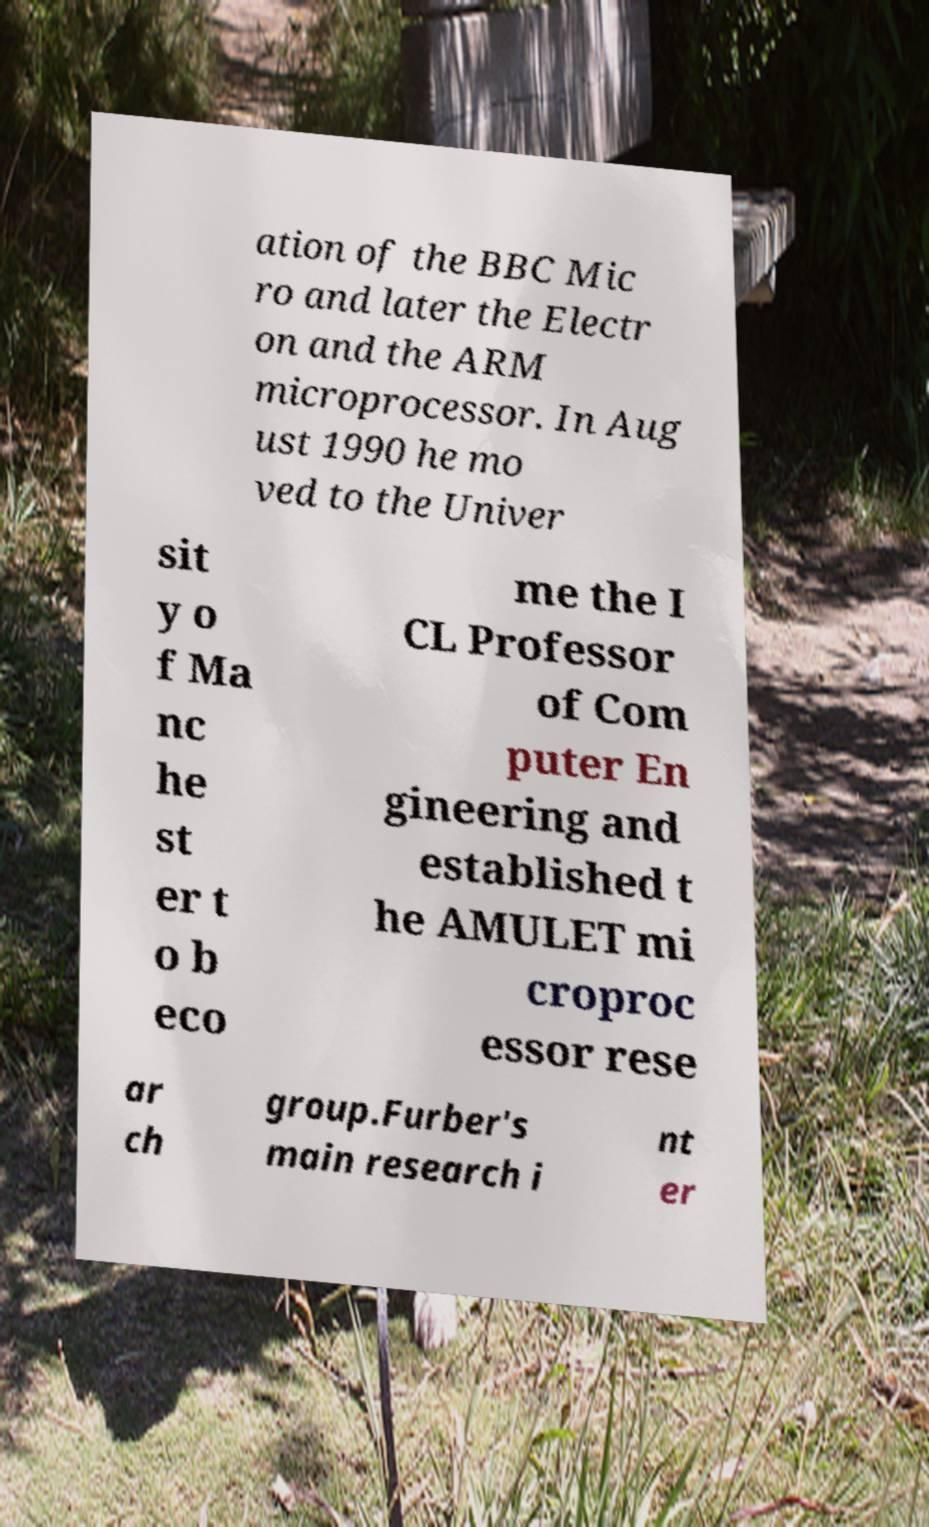Please identify and transcribe the text found in this image. ation of the BBC Mic ro and later the Electr on and the ARM microprocessor. In Aug ust 1990 he mo ved to the Univer sit y o f Ma nc he st er t o b eco me the I CL Professor of Com puter En gineering and established t he AMULET mi croproc essor rese ar ch group.Furber's main research i nt er 